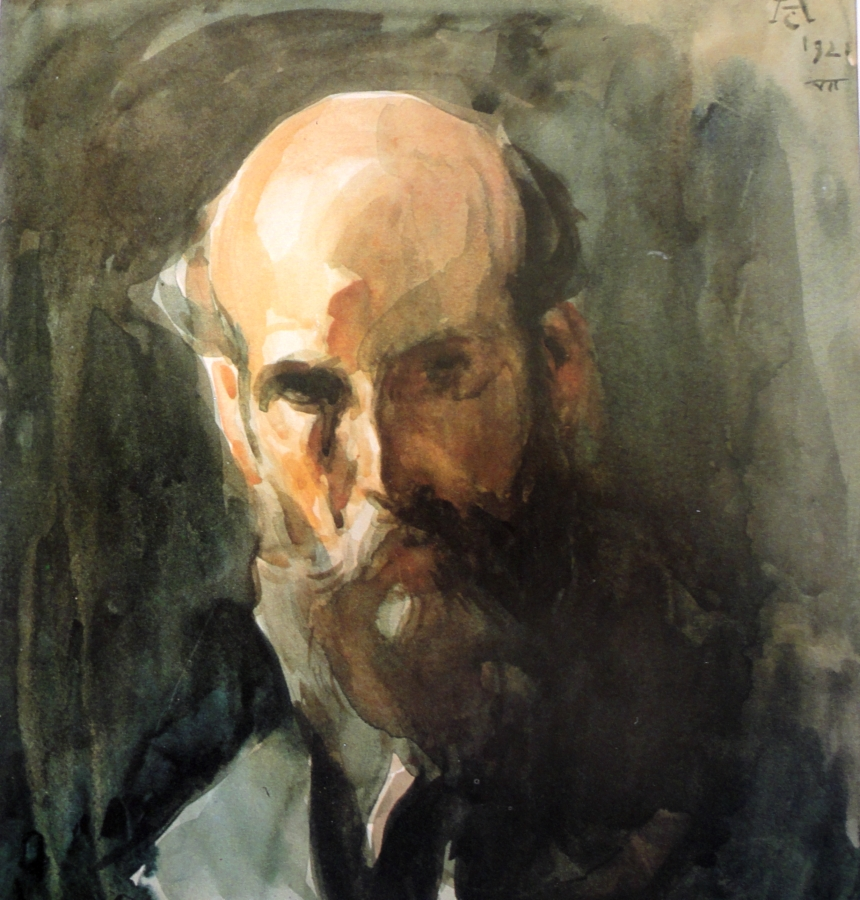If this painting were part of an art exhibition, what would the exhibition be called and why? The exhibition could be called 'Echoes of the Human Soul'. This title encapsulates the deep, introspective quality of the portraits, each one delving into the essence of its subject. The use of loose brushstrokes and abstract techniques allows the viewers to see beyond the physical appearance and connect with the emotions and stories conveyed through the paintings. 